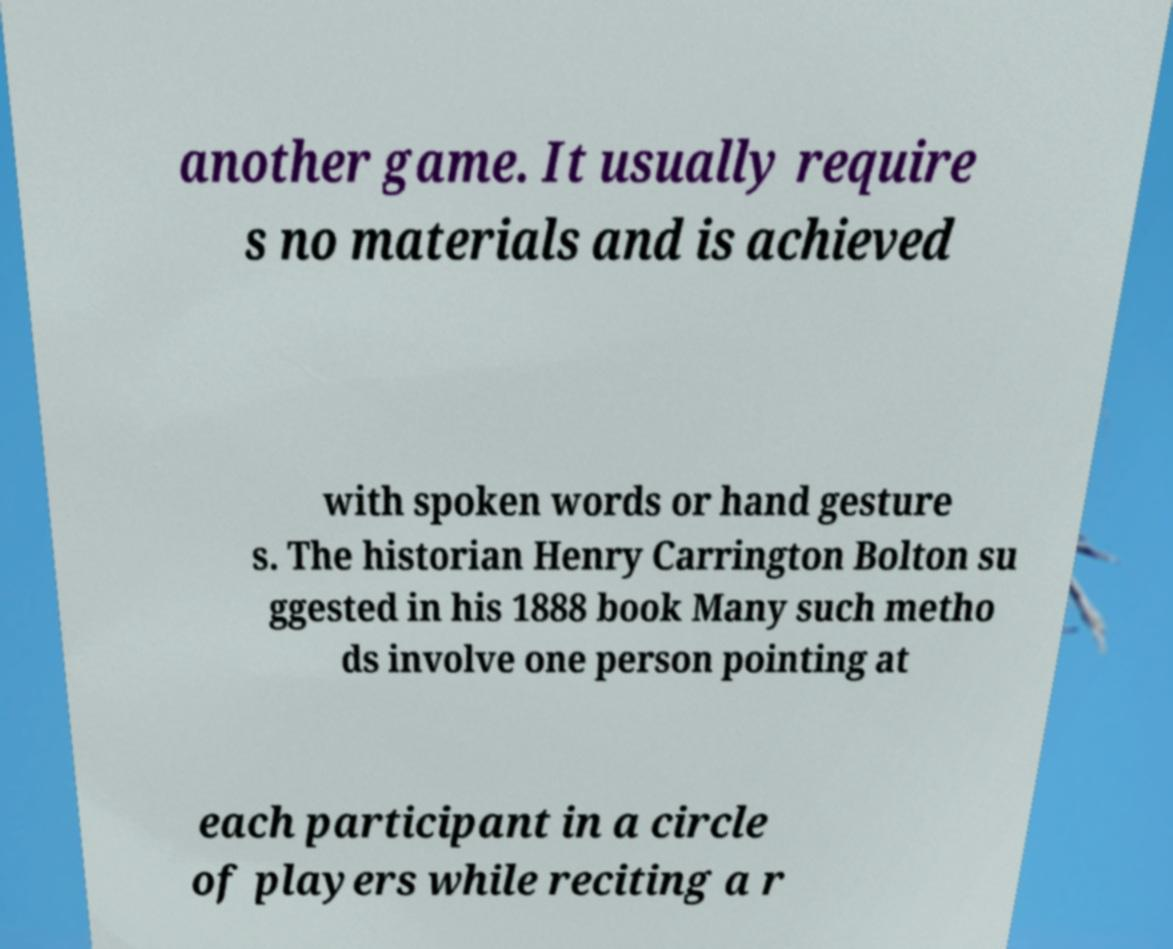Can you accurately transcribe the text from the provided image for me? another game. It usually require s no materials and is achieved with spoken words or hand gesture s. The historian Henry Carrington Bolton su ggested in his 1888 book Many such metho ds involve one person pointing at each participant in a circle of players while reciting a r 